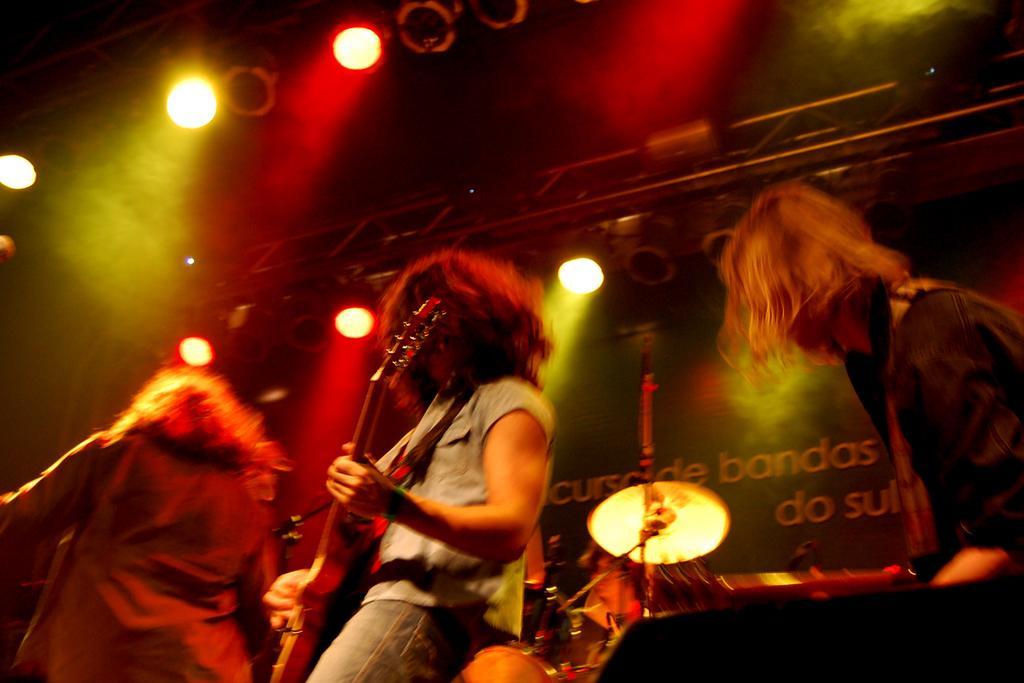Describe this image in one or two sentences. In this image I see 3 persons and in which one of them is holding a guitar. In the background I see the lights and a musical instrument. 